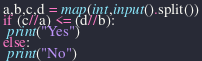<code> <loc_0><loc_0><loc_500><loc_500><_Python_>a,b,c,d = map(int,input().split())
if (c//a) <= (d//b):
 print("Yes")
else:
 print("No")</code> 